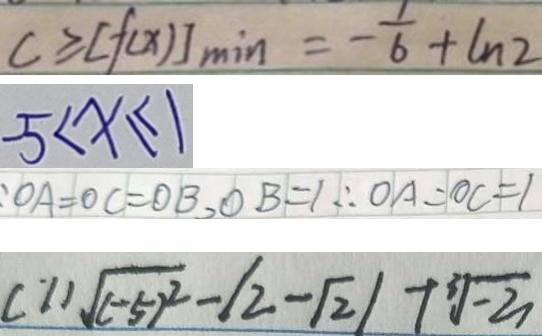Convert formula to latex. <formula><loc_0><loc_0><loc_500><loc_500>c \geq [ f ( x ) ] \min = - \frac { 1 } { 6 } + \ln 2 
 5 < x \leq 1 
 : O A = O C = O B , O B = 1 \therefore O A = O C = 1 
 ( 1 ) \sqrt { ( - 5 ) ^ { 2 } } - \vert 2 - \sqrt { 2 } \vert + \sqrt [ 3 ] { - 3 }</formula> 